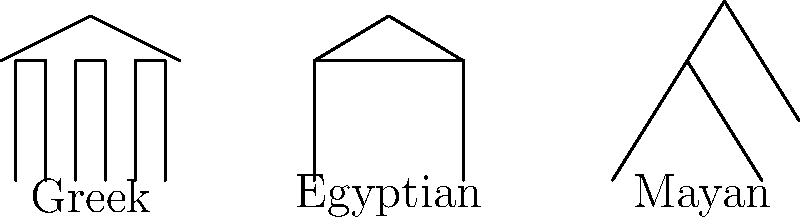As a magazine editor focusing on historical accuracy, which architectural style shown in the diagram is characterized by its use of multiple columns and a triangular pediment, reflecting its emphasis on symmetry and proportion? To answer this question, let's analyze each architectural style presented in the diagram:

1. Greek Architecture:
   - Multiple columns are clearly visible
   - A triangular roof structure (pediment) is present
   - The overall structure appears symmetrical

2. Egyptian Architecture:
   - Two large, block-like structures represent walls or pylons
   - A slightly sloped roof is visible
   - No columns are present in this simplified representation

3. Mayan Architecture:
   - A stepped pyramid structure is shown
   - No columns or pediment are visible

The Greek architectural style is known for its use of columns and pediments, which are both present in the leftmost structure in the diagram. This style emphasizes symmetry and proportion, as evidenced by the evenly spaced columns and balanced triangular roof.

The Egyptian style, while monumental, doesn't typically feature the same type of columned facade with a triangular pediment.

The Mayan style, represented by a pyramid structure, is distinctly different from both Greek and Egyptian styles and doesn't incorporate the elements mentioned in the question.

Therefore, the architectural style characterized by multiple columns and a triangular pediment, reflecting an emphasis on symmetry and proportion, is the Greek style.
Answer: Greek 